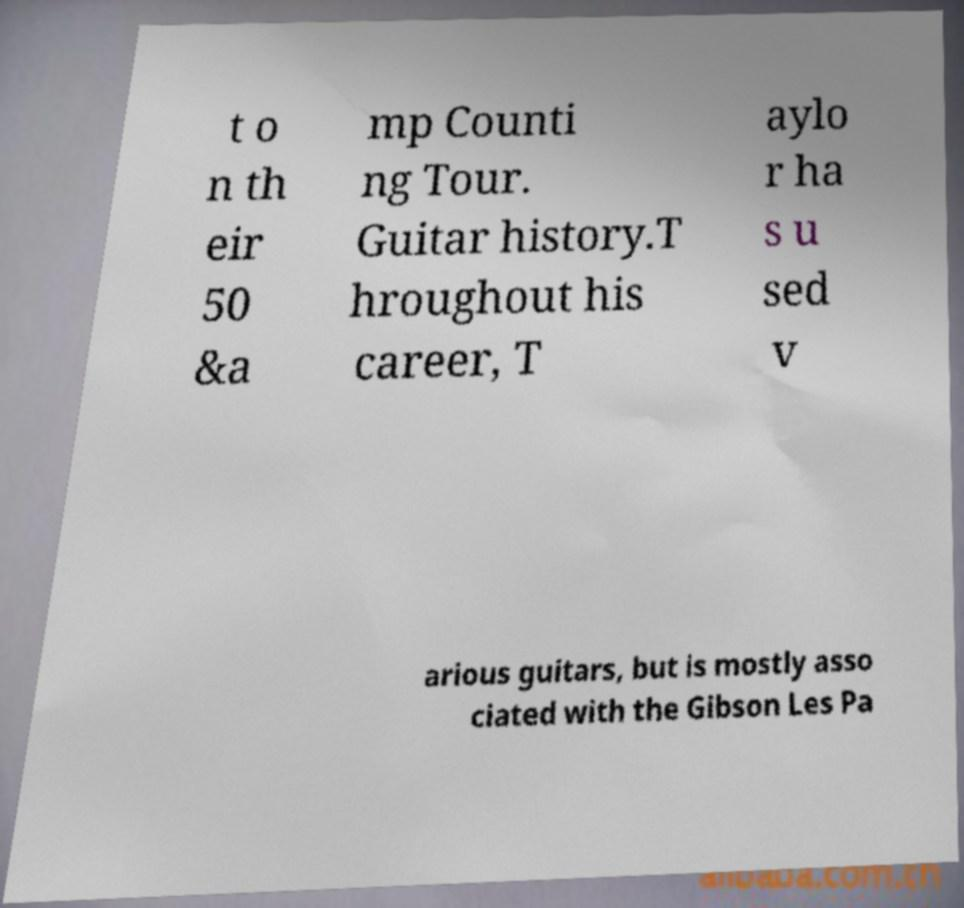For documentation purposes, I need the text within this image transcribed. Could you provide that? t o n th eir 50 &a mp Counti ng Tour. Guitar history.T hroughout his career, T aylo r ha s u sed v arious guitars, but is mostly asso ciated with the Gibson Les Pa 